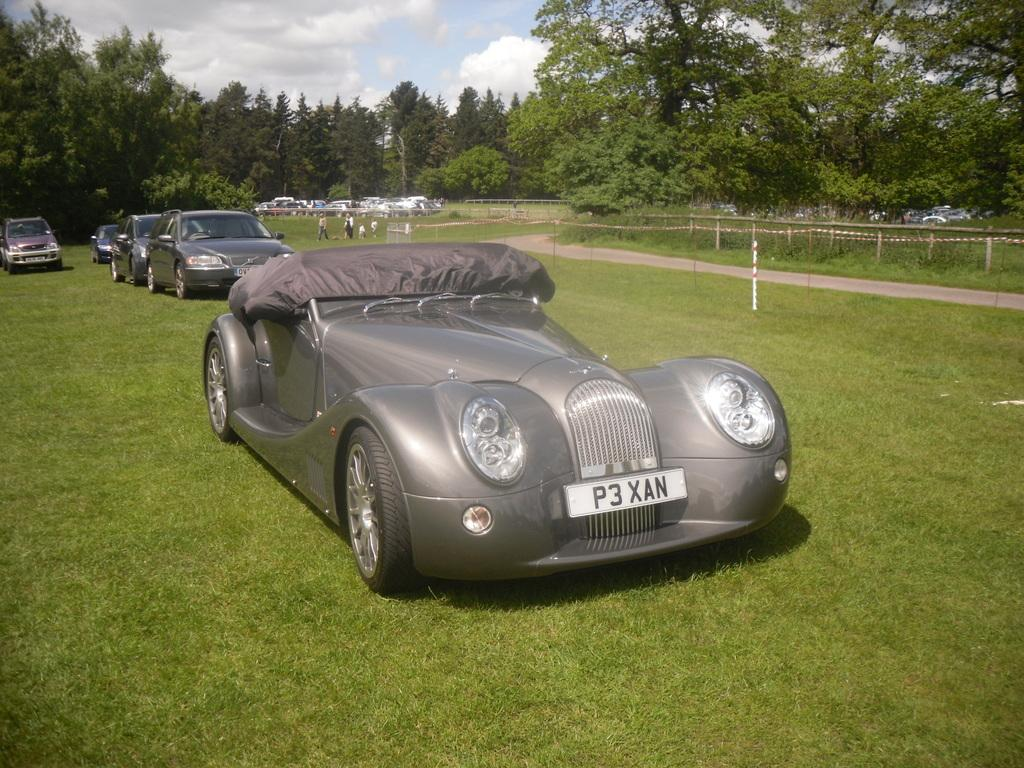What type of vehicles can be seen on the ground in the image? There are cars visible on the ground in the image. What is the purpose of the fence in the image? The purpose of the fence in the image is not specified, but it could be for enclosing an area or providing a barrier. What type of vegetation is in the middle of the image? There are trees in the middle of the image. What is visible at the top of the image? The sky is visible at the top of the image. Can you compare the size of the snake to the trees in the image? There is no snake present in the image, so it cannot be compared to the trees. What attraction is visible in the image? The image does not depict any specific attraction; it shows cars, a fence, trees, and the sky. 